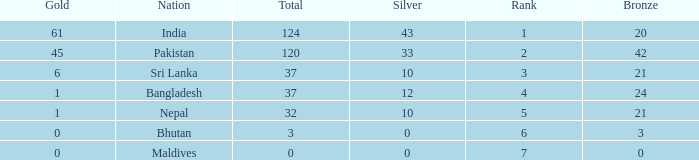Which Silver has a Rank of 6, and a Bronze smaller than 3? None. Could you parse the entire table as a dict? {'header': ['Gold', 'Nation', 'Total', 'Silver', 'Rank', 'Bronze'], 'rows': [['61', 'India', '124', '43', '1', '20'], ['45', 'Pakistan', '120', '33', '2', '42'], ['6', 'Sri Lanka', '37', '10', '3', '21'], ['1', 'Bangladesh', '37', '12', '4', '24'], ['1', 'Nepal', '32', '10', '5', '21'], ['0', 'Bhutan', '3', '0', '6', '3'], ['0', 'Maldives', '0', '0', '7', '0']]} 